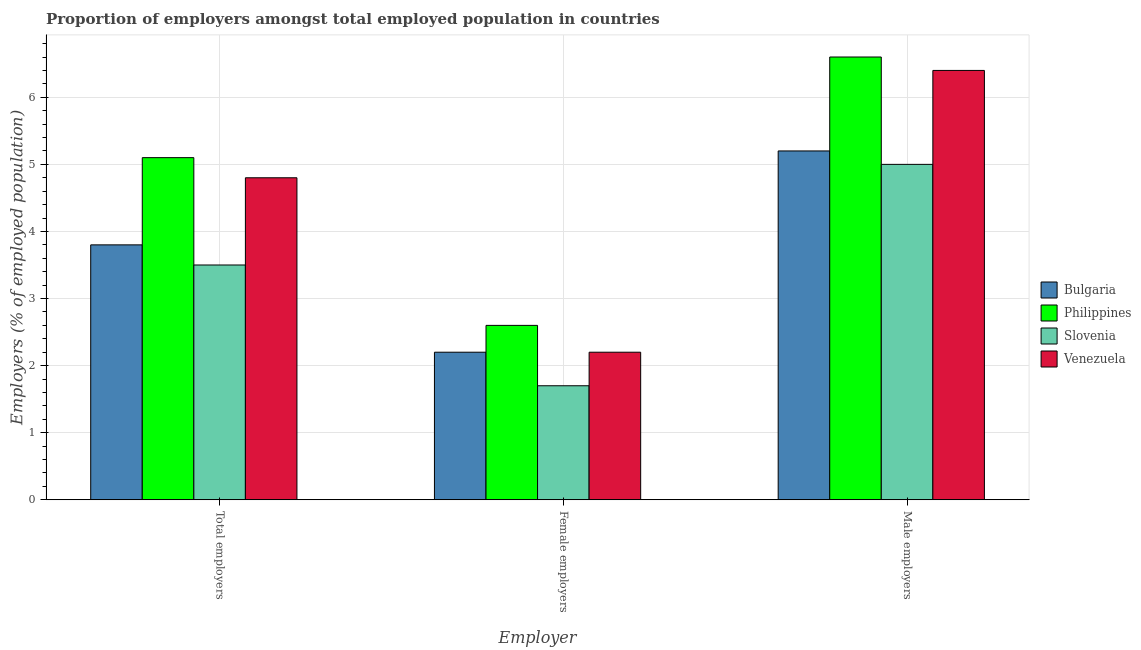How many groups of bars are there?
Your response must be concise. 3. Are the number of bars per tick equal to the number of legend labels?
Your answer should be very brief. Yes. Are the number of bars on each tick of the X-axis equal?
Ensure brevity in your answer.  Yes. How many bars are there on the 1st tick from the left?
Offer a very short reply. 4. How many bars are there on the 2nd tick from the right?
Provide a succinct answer. 4. What is the label of the 3rd group of bars from the left?
Provide a short and direct response. Male employers. What is the percentage of total employers in Venezuela?
Your answer should be very brief. 4.8. Across all countries, what is the maximum percentage of female employers?
Offer a very short reply. 2.6. Across all countries, what is the minimum percentage of female employers?
Offer a terse response. 1.7. In which country was the percentage of male employers minimum?
Provide a short and direct response. Slovenia. What is the total percentage of total employers in the graph?
Your response must be concise. 17.2. What is the difference between the percentage of total employers in Philippines and that in Slovenia?
Your answer should be very brief. 1.6. What is the difference between the percentage of female employers in Philippines and the percentage of male employers in Slovenia?
Your response must be concise. -2.4. What is the average percentage of total employers per country?
Offer a very short reply. 4.3. What is the difference between the percentage of male employers and percentage of female employers in Philippines?
Give a very brief answer. 4. What is the ratio of the percentage of male employers in Slovenia to that in Venezuela?
Offer a terse response. 0.78. Is the percentage of male employers in Bulgaria less than that in Slovenia?
Keep it short and to the point. No. Is the difference between the percentage of female employers in Venezuela and Bulgaria greater than the difference between the percentage of total employers in Venezuela and Bulgaria?
Give a very brief answer. No. What is the difference between the highest and the second highest percentage of male employers?
Provide a succinct answer. 0.2. What is the difference between the highest and the lowest percentage of female employers?
Offer a terse response. 0.9. In how many countries, is the percentage of total employers greater than the average percentage of total employers taken over all countries?
Keep it short and to the point. 2. What does the 2nd bar from the right in Female employers represents?
Offer a very short reply. Slovenia. Are all the bars in the graph horizontal?
Offer a terse response. No. What is the difference between two consecutive major ticks on the Y-axis?
Make the answer very short. 1. How are the legend labels stacked?
Provide a succinct answer. Vertical. What is the title of the graph?
Make the answer very short. Proportion of employers amongst total employed population in countries. What is the label or title of the X-axis?
Offer a terse response. Employer. What is the label or title of the Y-axis?
Offer a very short reply. Employers (% of employed population). What is the Employers (% of employed population) of Bulgaria in Total employers?
Your response must be concise. 3.8. What is the Employers (% of employed population) in Philippines in Total employers?
Make the answer very short. 5.1. What is the Employers (% of employed population) of Venezuela in Total employers?
Give a very brief answer. 4.8. What is the Employers (% of employed population) of Bulgaria in Female employers?
Ensure brevity in your answer.  2.2. What is the Employers (% of employed population) of Philippines in Female employers?
Offer a very short reply. 2.6. What is the Employers (% of employed population) of Slovenia in Female employers?
Your answer should be compact. 1.7. What is the Employers (% of employed population) in Venezuela in Female employers?
Give a very brief answer. 2.2. What is the Employers (% of employed population) in Bulgaria in Male employers?
Offer a very short reply. 5.2. What is the Employers (% of employed population) in Philippines in Male employers?
Provide a succinct answer. 6.6. What is the Employers (% of employed population) in Venezuela in Male employers?
Keep it short and to the point. 6.4. Across all Employer, what is the maximum Employers (% of employed population) in Bulgaria?
Provide a short and direct response. 5.2. Across all Employer, what is the maximum Employers (% of employed population) in Philippines?
Offer a very short reply. 6.6. Across all Employer, what is the maximum Employers (% of employed population) in Slovenia?
Your answer should be compact. 5. Across all Employer, what is the maximum Employers (% of employed population) in Venezuela?
Your response must be concise. 6.4. Across all Employer, what is the minimum Employers (% of employed population) in Bulgaria?
Make the answer very short. 2.2. Across all Employer, what is the minimum Employers (% of employed population) in Philippines?
Your answer should be very brief. 2.6. Across all Employer, what is the minimum Employers (% of employed population) in Slovenia?
Offer a terse response. 1.7. Across all Employer, what is the minimum Employers (% of employed population) of Venezuela?
Provide a succinct answer. 2.2. What is the total Employers (% of employed population) of Bulgaria in the graph?
Offer a terse response. 11.2. What is the total Employers (% of employed population) of Venezuela in the graph?
Offer a terse response. 13.4. What is the difference between the Employers (% of employed population) in Bulgaria in Total employers and that in Female employers?
Your response must be concise. 1.6. What is the difference between the Employers (% of employed population) in Slovenia in Total employers and that in Female employers?
Provide a short and direct response. 1.8. What is the difference between the Employers (% of employed population) in Bulgaria in Total employers and that in Male employers?
Provide a short and direct response. -1.4. What is the difference between the Employers (% of employed population) of Venezuela in Total employers and that in Male employers?
Make the answer very short. -1.6. What is the difference between the Employers (% of employed population) of Slovenia in Female employers and that in Male employers?
Offer a terse response. -3.3. What is the difference between the Employers (% of employed population) of Bulgaria in Total employers and the Employers (% of employed population) of Slovenia in Female employers?
Keep it short and to the point. 2.1. What is the difference between the Employers (% of employed population) of Slovenia in Total employers and the Employers (% of employed population) of Venezuela in Female employers?
Your answer should be compact. 1.3. What is the difference between the Employers (% of employed population) of Bulgaria in Total employers and the Employers (% of employed population) of Venezuela in Male employers?
Provide a succinct answer. -2.6. What is the difference between the Employers (% of employed population) in Philippines in Total employers and the Employers (% of employed population) in Venezuela in Male employers?
Offer a terse response. -1.3. What is the difference between the Employers (% of employed population) in Slovenia in Total employers and the Employers (% of employed population) in Venezuela in Male employers?
Make the answer very short. -2.9. What is the difference between the Employers (% of employed population) in Bulgaria in Female employers and the Employers (% of employed population) in Philippines in Male employers?
Your answer should be very brief. -4.4. What is the difference between the Employers (% of employed population) in Bulgaria in Female employers and the Employers (% of employed population) in Slovenia in Male employers?
Ensure brevity in your answer.  -2.8. What is the difference between the Employers (% of employed population) in Bulgaria in Female employers and the Employers (% of employed population) in Venezuela in Male employers?
Offer a terse response. -4.2. What is the average Employers (% of employed population) of Bulgaria per Employer?
Make the answer very short. 3.73. What is the average Employers (% of employed population) in Philippines per Employer?
Provide a short and direct response. 4.77. What is the average Employers (% of employed population) of Slovenia per Employer?
Ensure brevity in your answer.  3.4. What is the average Employers (% of employed population) of Venezuela per Employer?
Offer a terse response. 4.47. What is the difference between the Employers (% of employed population) in Philippines and Employers (% of employed population) in Venezuela in Total employers?
Your answer should be very brief. 0.3. What is the difference between the Employers (% of employed population) in Slovenia and Employers (% of employed population) in Venezuela in Total employers?
Give a very brief answer. -1.3. What is the difference between the Employers (% of employed population) in Bulgaria and Employers (% of employed population) in Venezuela in Female employers?
Your answer should be compact. 0. What is the difference between the Employers (% of employed population) in Philippines and Employers (% of employed population) in Venezuela in Female employers?
Provide a succinct answer. 0.4. What is the difference between the Employers (% of employed population) in Slovenia and Employers (% of employed population) in Venezuela in Female employers?
Provide a short and direct response. -0.5. What is the difference between the Employers (% of employed population) in Bulgaria and Employers (% of employed population) in Philippines in Male employers?
Give a very brief answer. -1.4. What is the difference between the Employers (% of employed population) in Bulgaria and Employers (% of employed population) in Slovenia in Male employers?
Ensure brevity in your answer.  0.2. What is the difference between the Employers (% of employed population) in Philippines and Employers (% of employed population) in Slovenia in Male employers?
Make the answer very short. 1.6. What is the ratio of the Employers (% of employed population) in Bulgaria in Total employers to that in Female employers?
Offer a very short reply. 1.73. What is the ratio of the Employers (% of employed population) in Philippines in Total employers to that in Female employers?
Provide a short and direct response. 1.96. What is the ratio of the Employers (% of employed population) in Slovenia in Total employers to that in Female employers?
Give a very brief answer. 2.06. What is the ratio of the Employers (% of employed population) in Venezuela in Total employers to that in Female employers?
Make the answer very short. 2.18. What is the ratio of the Employers (% of employed population) in Bulgaria in Total employers to that in Male employers?
Provide a succinct answer. 0.73. What is the ratio of the Employers (% of employed population) in Philippines in Total employers to that in Male employers?
Your answer should be very brief. 0.77. What is the ratio of the Employers (% of employed population) in Slovenia in Total employers to that in Male employers?
Give a very brief answer. 0.7. What is the ratio of the Employers (% of employed population) of Venezuela in Total employers to that in Male employers?
Your answer should be compact. 0.75. What is the ratio of the Employers (% of employed population) in Bulgaria in Female employers to that in Male employers?
Offer a very short reply. 0.42. What is the ratio of the Employers (% of employed population) of Philippines in Female employers to that in Male employers?
Provide a short and direct response. 0.39. What is the ratio of the Employers (% of employed population) of Slovenia in Female employers to that in Male employers?
Provide a short and direct response. 0.34. What is the ratio of the Employers (% of employed population) in Venezuela in Female employers to that in Male employers?
Your response must be concise. 0.34. What is the difference between the highest and the second highest Employers (% of employed population) in Bulgaria?
Provide a short and direct response. 1.4. What is the difference between the highest and the lowest Employers (% of employed population) in Philippines?
Ensure brevity in your answer.  4. What is the difference between the highest and the lowest Employers (% of employed population) of Slovenia?
Ensure brevity in your answer.  3.3. 